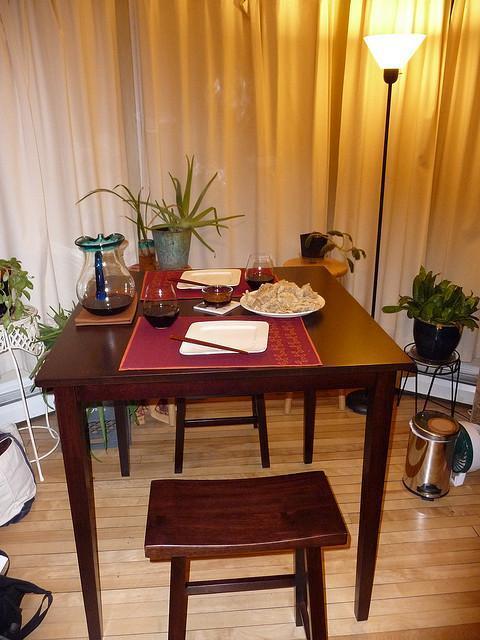How many people could sit at this table?
Give a very brief answer. 2. How many potted plants can be seen?
Give a very brief answer. 3. How many chairs are there?
Give a very brief answer. 2. How many people are in the photo?
Give a very brief answer. 0. 